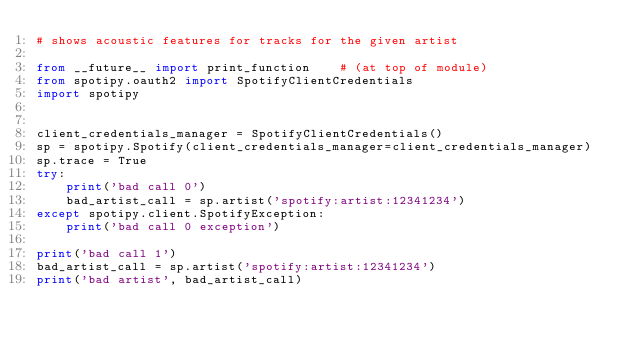<code> <loc_0><loc_0><loc_500><loc_500><_Python_># shows acoustic features for tracks for the given artist

from __future__ import print_function    # (at top of module)
from spotipy.oauth2 import SpotifyClientCredentials
import spotipy


client_credentials_manager = SpotifyClientCredentials()
sp = spotipy.Spotify(client_credentials_manager=client_credentials_manager)
sp.trace = True
try:
    print('bad call 0')
    bad_artist_call = sp.artist('spotify:artist:12341234')
except spotipy.client.SpotifyException:
    print('bad call 0 exception')

print('bad call 1')
bad_artist_call = sp.artist('spotify:artist:12341234')
print('bad artist', bad_artist_call)
</code> 